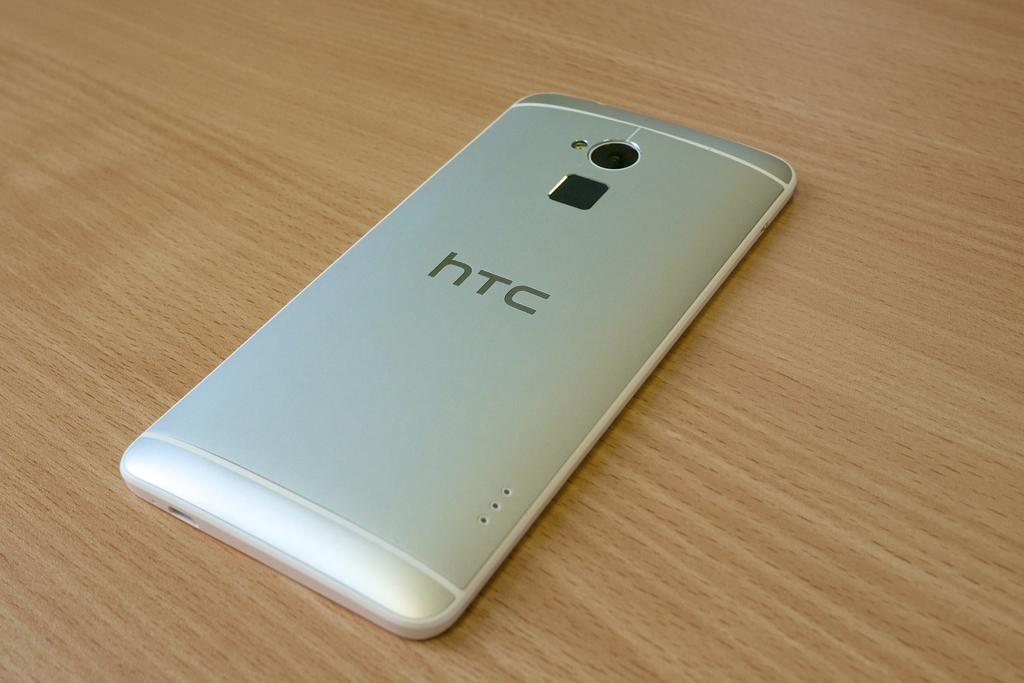<image>
Give a short and clear explanation of the subsequent image. The back side of a HTC cell phone on a table. 